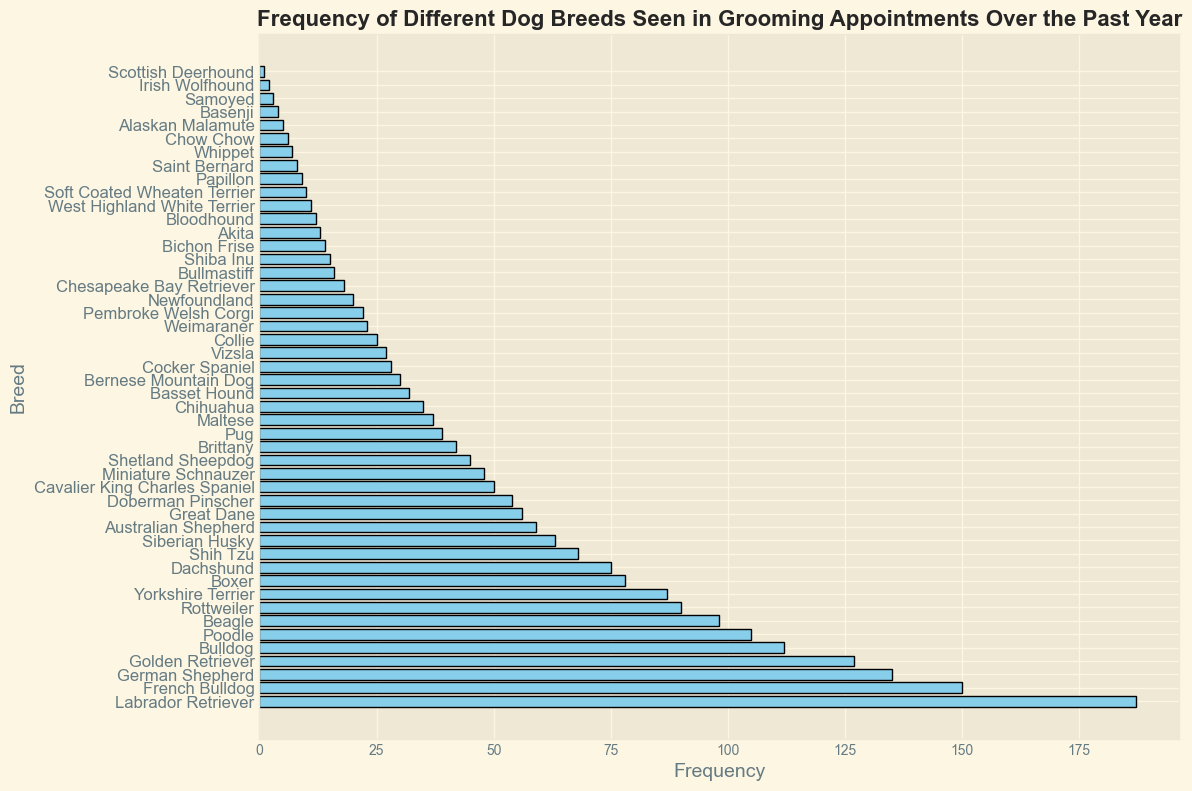Which dog breed is seen most frequently in grooming appointments over the past year? The bar representing Labrador Retriever is the longest in the histogram, indicating it has the highest frequency.
Answer: Labrador Retriever What is the combined frequency of German Shepherds and Bulldogs seen in grooming appointments over the past year? The frequency of German Shepherds is 135 and Bulldogs is 112. Adding them together, 135 + 112 = 247.
Answer: 247 How many more French Bulldogs are seen than Bichon Frises? French Bulldogs have a frequency of 150 while Bichon Frises have a frequency of 14. Subtracting these, 150 - 14 = 136.
Answer: 136 Which of the following breeds has a lower frequency: Boxer or Dachshund? By looking at the length of their bars, the Boxer's frequency is 78 and the Dachshund's frequency is 75. Since 75 is less than 78, Dachshund has a lower frequency.
Answer: Dachshund What is the median frequency of all the dog breeds? With 50 breeds listed, the median is the average of the 25th and 26th values once sorted by frequency. After sorting the values, the 25th breed (Basset Hound) has a frequency of 32 and the 26th breed (Bernese Mountain Dog) has a frequency of 30. Taking the average, (32 + 30) / 2 = 31.
Answer: 31 Are there more Rottweilers or more Siberian Huskies? The frequency of Rottweilers is 90 and Siberian Huskies is 63. Rottweiler has a longer bar, indicating a higher frequency.
Answer: Rottweilers How does the frequency of Chihuahua compare to Maltese? The histogram shows Chihuahuas have a frequency of 35 and Maltese have a frequency of 37. Maltese has a slightly higher frequency.
Answer: Maltese What is the total frequency of the top three most groomed breeds? The highest frequencies are Labrador Retrievers (187), French Bulldogs (150), and German Shepherds (135). Adding them together, 187 + 150 + 135 = 472.
Answer: 472 Which breed among Shih Tzu, Siberian Husky, and Australian Shepherd has the lowest frequency? Their frequencies are Shih Tzu (68), Siberian Husky (63), and Australian Shepherd (59). Australian Shepherd has the lowest frequency.
Answer: Australian Shepherd What is the frequency difference between the highest and lowest seen breeds? The highest is Labrador Retriever (187) and the lowest is Scottish Deerhound (1). Subtracting these, 187 - 1 = 186.
Answer: 186 